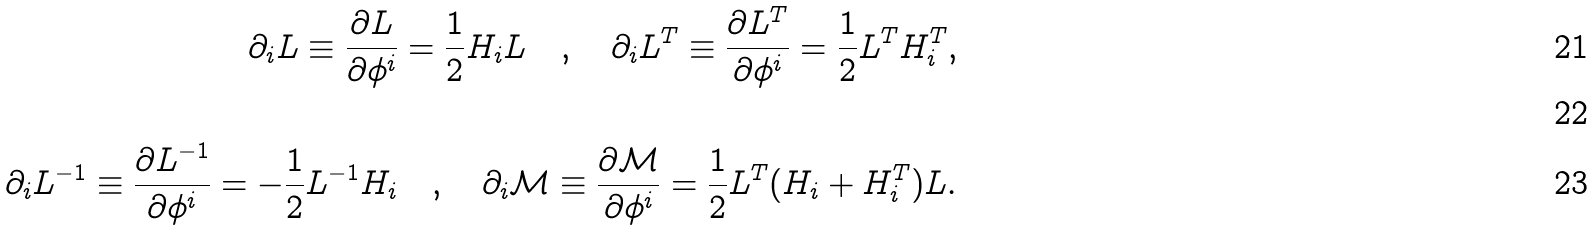Convert formula to latex. <formula><loc_0><loc_0><loc_500><loc_500>\partial _ { i } L \equiv \frac { \partial L } { \partial \phi ^ { i } } = \frac { 1 } { 2 } H _ { i } L \quad , \quad \partial _ { i } L ^ { T } \equiv \frac { \partial L ^ { T } } { \partial \phi ^ { i } } = \frac { 1 } { 2 } L ^ { T } H _ { i } ^ { T } , \\ \\ \partial _ { i } L ^ { - 1 } \equiv \frac { \partial L ^ { - 1 } } { \partial \phi ^ { i } } = - \frac { 1 } { 2 } L ^ { - 1 } H _ { i } \quad , \quad \partial _ { i } \mathcal { M } \equiv \frac { \partial \mathcal { M } } { \partial \phi ^ { i } } = \frac { 1 } { 2 } L ^ { T } ( H _ { i } + H _ { i } ^ { T } ) L .</formula> 